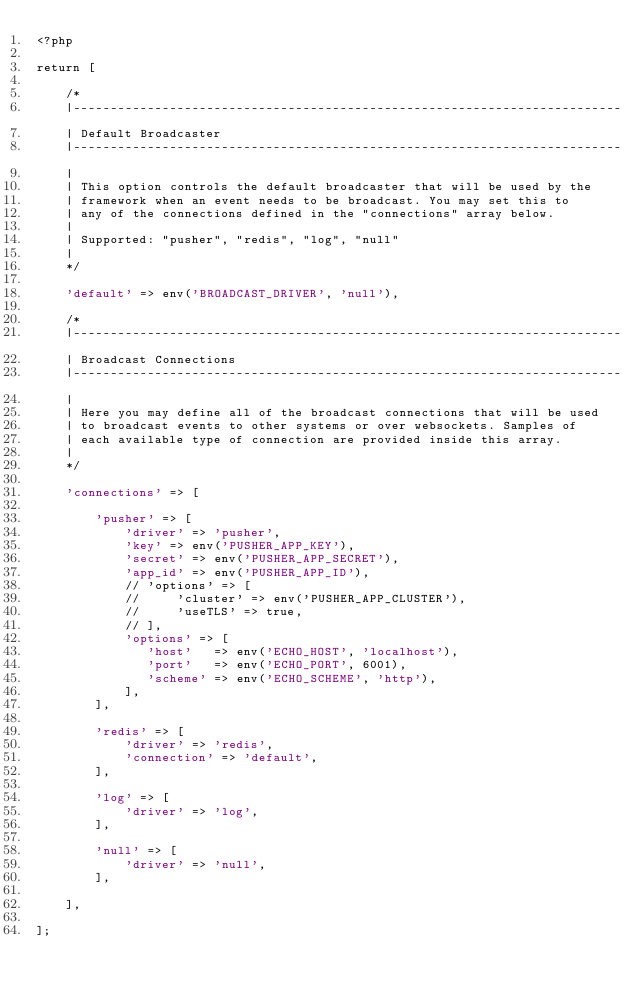Convert code to text. <code><loc_0><loc_0><loc_500><loc_500><_PHP_><?php

return [

    /*
    |--------------------------------------------------------------------------
    | Default Broadcaster
    |--------------------------------------------------------------------------
    |
    | This option controls the default broadcaster that will be used by the
    | framework when an event needs to be broadcast. You may set this to
    | any of the connections defined in the "connections" array below.
    |
    | Supported: "pusher", "redis", "log", "null"
    |
    */

    'default' => env('BROADCAST_DRIVER', 'null'),

    /*
    |--------------------------------------------------------------------------
    | Broadcast Connections
    |--------------------------------------------------------------------------
    |
    | Here you may define all of the broadcast connections that will be used
    | to broadcast events to other systems or over websockets. Samples of
    | each available type of connection are provided inside this array.
    |
    */

    'connections' => [

        'pusher' => [
            'driver' => 'pusher',
            'key' => env('PUSHER_APP_KEY'),
            'secret' => env('PUSHER_APP_SECRET'),
            'app_id' => env('PUSHER_APP_ID'),
            // 'options' => [
            //     'cluster' => env('PUSHER_APP_CLUSTER'),
            //     'useTLS' => true,
            // ],
            'options' => [
               'host'   => env('ECHO_HOST', 'localhost'),
               'port'   => env('ECHO_PORT', 6001),
               'scheme' => env('ECHO_SCHEME', 'http'),
            ],
        ],

        'redis' => [
            'driver' => 'redis',
            'connection' => 'default',
        ],

        'log' => [
            'driver' => 'log',
        ],

        'null' => [
            'driver' => 'null',
        ],

    ],

];
</code> 